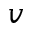Convert formula to latex. <formula><loc_0><loc_0><loc_500><loc_500>v</formula> 